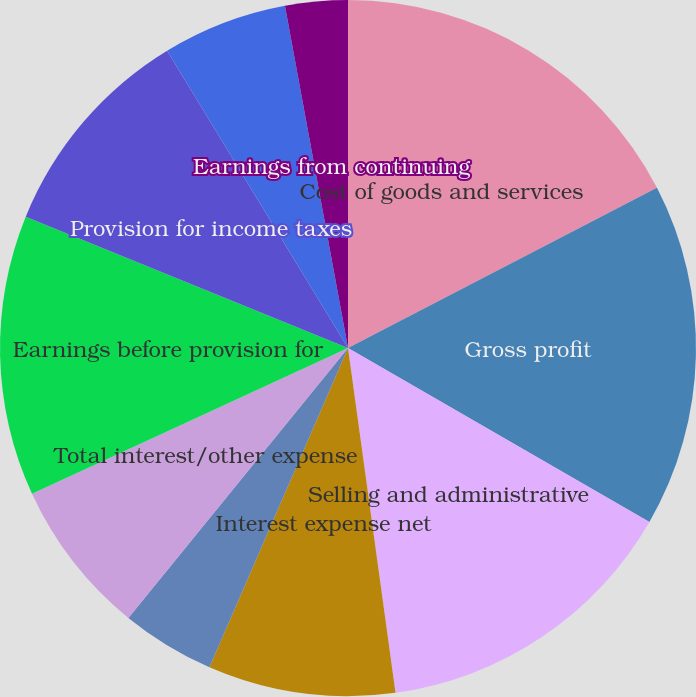<chart> <loc_0><loc_0><loc_500><loc_500><pie_chart><fcel>Cost of goods and services<fcel>Gross profit<fcel>Selling and administrative<fcel>Interest expense net<fcel>Other expense (income) net<fcel>Total interest/other expense<fcel>Earnings before provision for<fcel>Provision for income taxes<fcel>Loss from discontinued<fcel>Earnings from continuing<nl><fcel>17.39%<fcel>15.94%<fcel>14.49%<fcel>8.7%<fcel>4.35%<fcel>7.25%<fcel>13.04%<fcel>10.14%<fcel>5.8%<fcel>2.9%<nl></chart> 